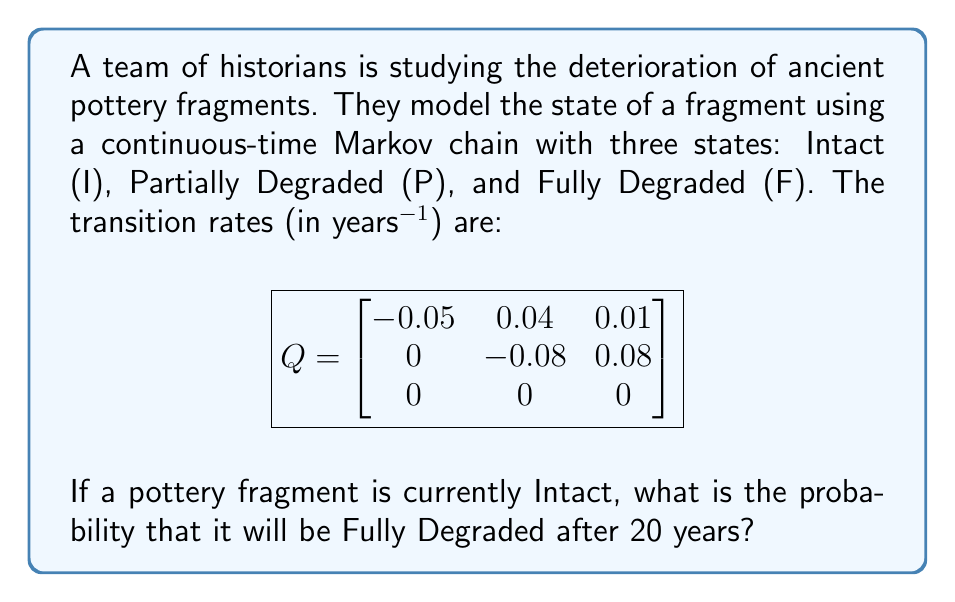Provide a solution to this math problem. To solve this problem, we need to calculate the transition probability matrix P(t) for t = 20 years. We can use the formula:

$$P(t) = e^{Qt}$$

Where Q is the given transition rate matrix and t = 20.

Step 1: Calculate Qt
$$
Qt = 20 \cdot \begin{bmatrix}
-0.05 & 0.04 & 0.01 \\
0 & -0.08 & 0.08 \\
0 & 0 & 0
\end{bmatrix} = \begin{bmatrix}
-1 & 0.8 & 0.2 \\
0 & -1.6 & 1.6 \\
0 & 0 & 0
\end{bmatrix}
$$

Step 2: Calculate e^(Qt) using the matrix exponential
To simplify this calculation, we can use the fact that the matrix is upper triangular. For upper triangular matrices, the diagonal elements of e^(Qt) are e^(diagonal elements of Qt).

$$
e^{Qt} = \begin{bmatrix}
e^{-1} & * & * \\
0 & e^{-1.6} & * \\
0 & 0 & 1
\end{bmatrix}
$$

Where * represents non-zero elements that we need to calculate.

Step 3: Calculate the off-diagonal elements
For the (1,2) element:
$$(e^{Qt})_{12} = \frac{0.8}{-0.05 - (-0.08)}(e^{-1.6} - e^{-1}) = 0.4918$$

For the (1,3) element:
$$(e^{Qt})_{13} = \frac{0.01}{0.05^2} e^{-1} + \frac{0.04 \cdot 0.08}{0.05 \cdot 0.03}(e^{-1} - e^{-1.6}) = 0.1696$$

For the (2,3) element:
$$(e^{Qt})_{23} = \frac{0.08}{0.08}(1 - e^{-1.6}) = 0.7981$$

Step 4: Write the complete transition probability matrix
$$
P(20) = e^{Qt} = \begin{bmatrix}
0.3679 & 0.4918 & 0.1696 \\
0 & 0.2019 & 0.7981 \\
0 & 0 & 1
\end{bmatrix}
$$

The probability of transitioning from Intact (I) to Fully Degraded (F) after 20 years is given by the element in the first row, third column of P(20), which is 0.1696.
Answer: 0.1696 